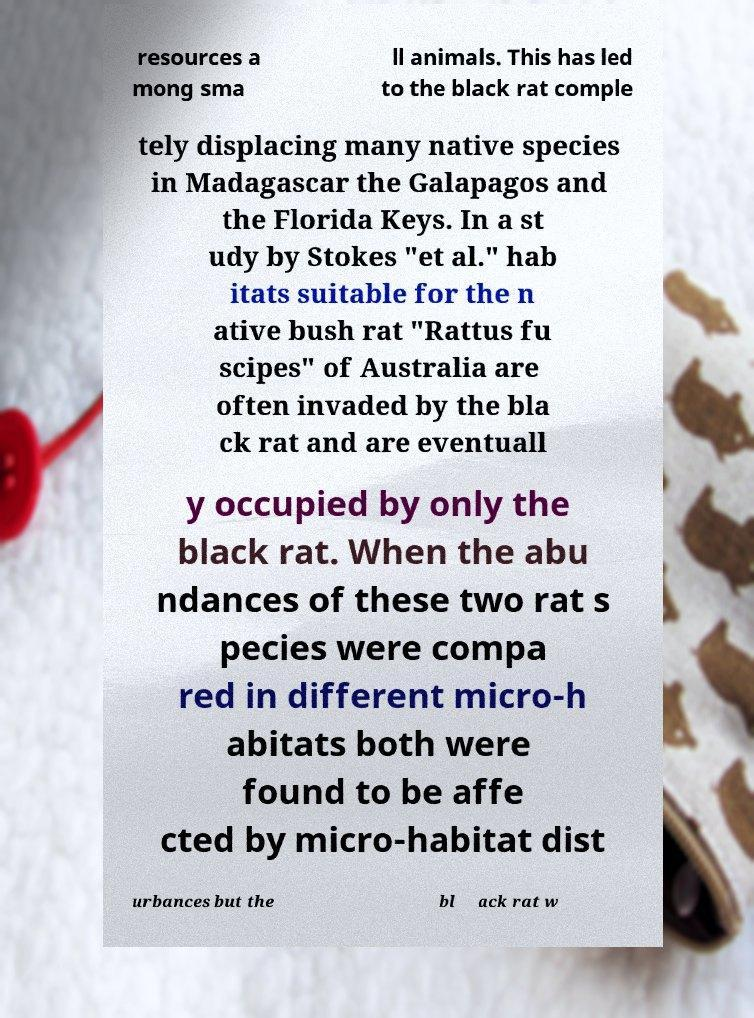What messages or text are displayed in this image? I need them in a readable, typed format. resources a mong sma ll animals. This has led to the black rat comple tely displacing many native species in Madagascar the Galapagos and the Florida Keys. In a st udy by Stokes "et al." hab itats suitable for the n ative bush rat "Rattus fu scipes" of Australia are often invaded by the bla ck rat and are eventuall y occupied by only the black rat. When the abu ndances of these two rat s pecies were compa red in different micro-h abitats both were found to be affe cted by micro-habitat dist urbances but the bl ack rat w 